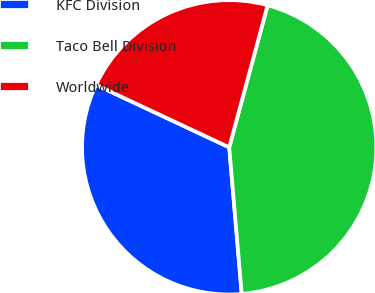Convert chart. <chart><loc_0><loc_0><loc_500><loc_500><pie_chart><fcel>KFC Division<fcel>Taco Bell Division<fcel>Worldwide<nl><fcel>33.33%<fcel>44.44%<fcel>22.22%<nl></chart> 